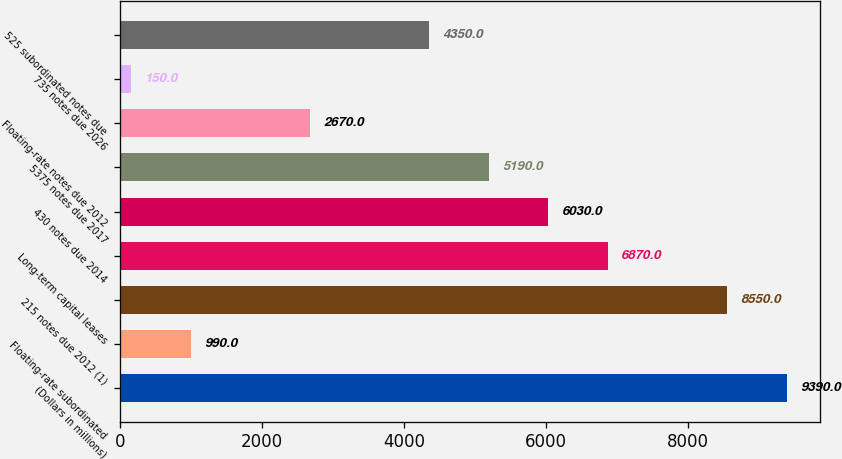<chart> <loc_0><loc_0><loc_500><loc_500><bar_chart><fcel>(Dollars in millions)<fcel>Floating-rate subordinated<fcel>215 notes due 2012 (1)<fcel>Long-term capital leases<fcel>430 notes due 2014<fcel>5375 notes due 2017<fcel>Floating-rate notes due 2012<fcel>735 notes due 2026<fcel>525 subordinated notes due<nl><fcel>9390<fcel>990<fcel>8550<fcel>6870<fcel>6030<fcel>5190<fcel>2670<fcel>150<fcel>4350<nl></chart> 